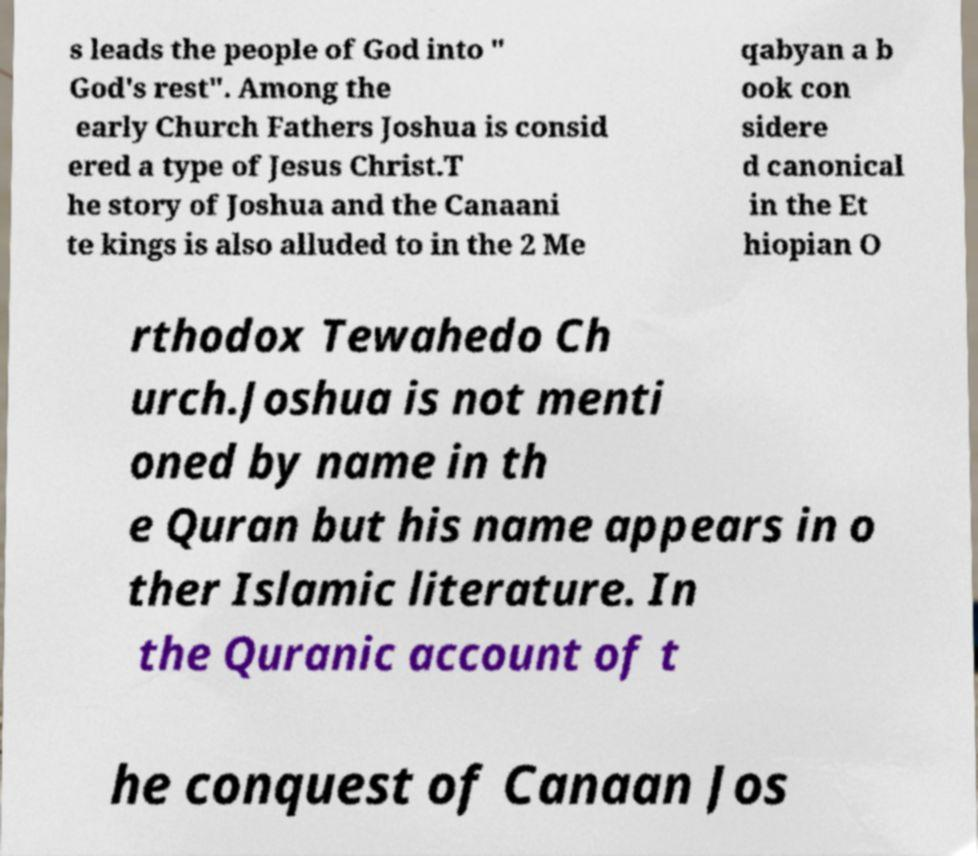Please identify and transcribe the text found in this image. s leads the people of God into " God's rest". Among the early Church Fathers Joshua is consid ered a type of Jesus Christ.T he story of Joshua and the Canaani te kings is also alluded to in the 2 Me qabyan a b ook con sidere d canonical in the Et hiopian O rthodox Tewahedo Ch urch.Joshua is not menti oned by name in th e Quran but his name appears in o ther Islamic literature. In the Quranic account of t he conquest of Canaan Jos 